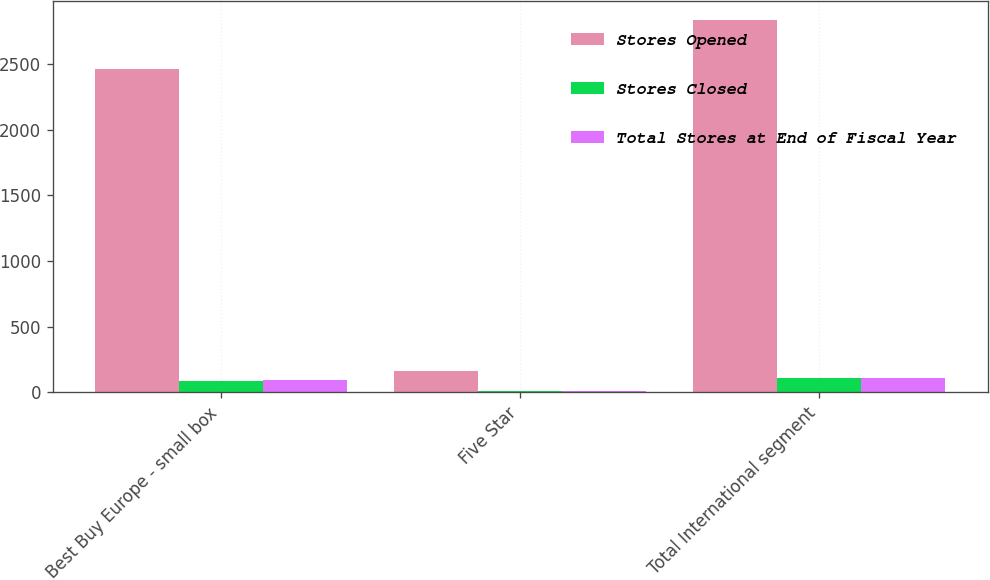<chart> <loc_0><loc_0><loc_500><loc_500><stacked_bar_chart><ecel><fcel>Best Buy Europe - small box<fcel>Five Star<fcel>Total International segment<nl><fcel>Stores Opened<fcel>2465<fcel>164<fcel>2835<nl><fcel>Stores Closed<fcel>82<fcel>6<fcel>106<nl><fcel>Total Stores at End of Fiscal Year<fcel>94<fcel>12<fcel>106<nl></chart> 